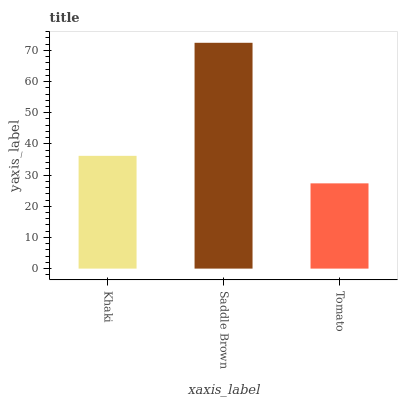Is Tomato the minimum?
Answer yes or no. Yes. Is Saddle Brown the maximum?
Answer yes or no. Yes. Is Saddle Brown the minimum?
Answer yes or no. No. Is Tomato the maximum?
Answer yes or no. No. Is Saddle Brown greater than Tomato?
Answer yes or no. Yes. Is Tomato less than Saddle Brown?
Answer yes or no. Yes. Is Tomato greater than Saddle Brown?
Answer yes or no. No. Is Saddle Brown less than Tomato?
Answer yes or no. No. Is Khaki the high median?
Answer yes or no. Yes. Is Khaki the low median?
Answer yes or no. Yes. Is Tomato the high median?
Answer yes or no. No. Is Saddle Brown the low median?
Answer yes or no. No. 